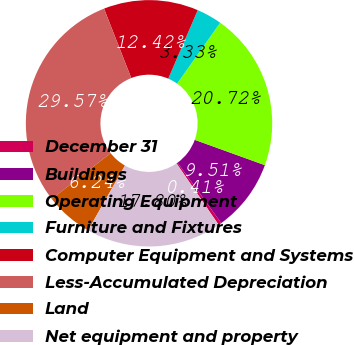Convert chart to OTSL. <chart><loc_0><loc_0><loc_500><loc_500><pie_chart><fcel>December 31<fcel>Buildings<fcel>Operating Equipment<fcel>Furniture and Fixtures<fcel>Computer Equipment and Systems<fcel>Less-Accumulated Depreciation<fcel>Land<fcel>Net equipment and property<nl><fcel>0.41%<fcel>9.51%<fcel>20.72%<fcel>3.33%<fcel>12.42%<fcel>29.57%<fcel>6.24%<fcel>17.8%<nl></chart> 